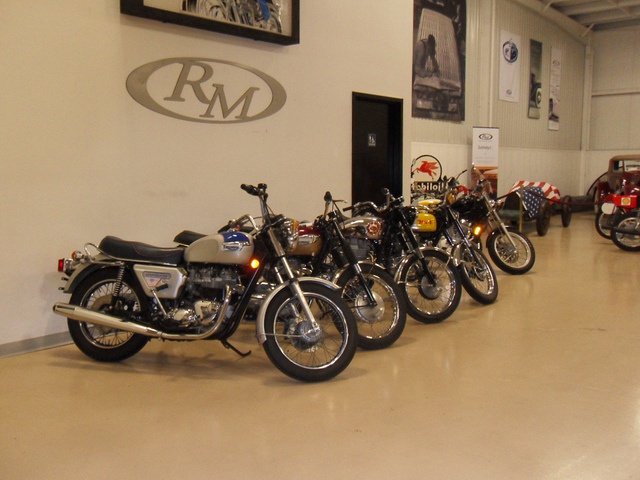Describe the objects in this image and their specific colors. I can see motorcycle in tan, black, gray, and maroon tones, motorcycle in tan, black, maroon, and gray tones, motorcycle in tan, black, maroon, and gray tones, motorcycle in tan, black, maroon, and gray tones, and motorcycle in tan, black, maroon, and gray tones in this image. 